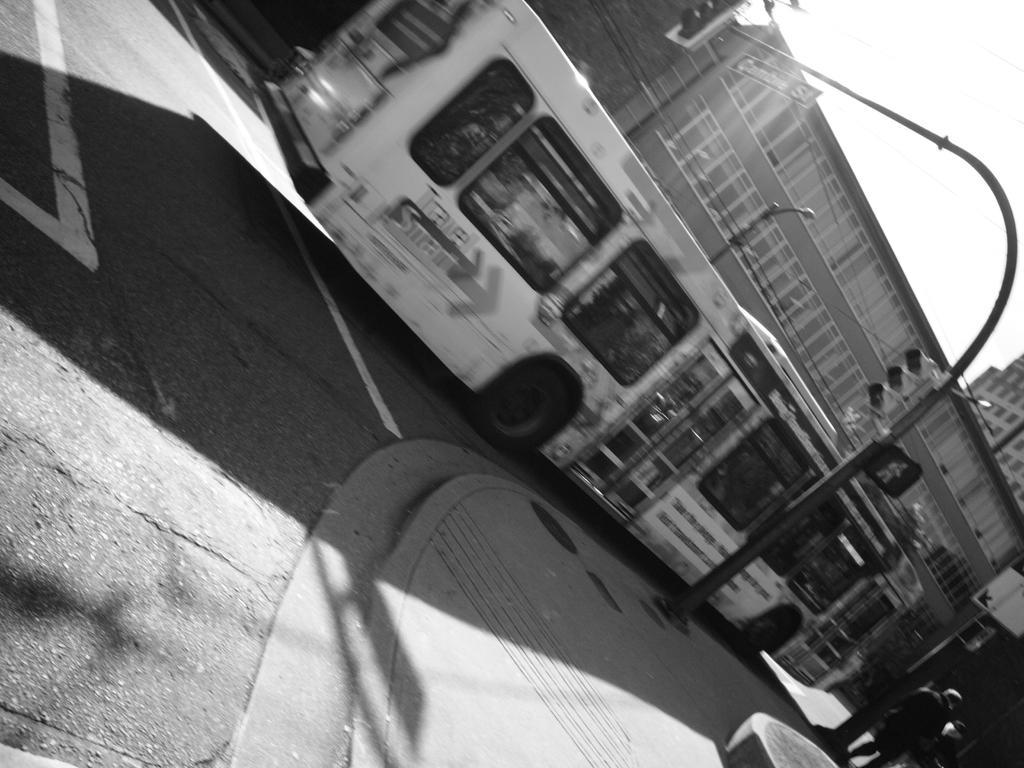Could you give a brief overview of what you see in this image? This is a black and white image. In this image, in the right corner, we can also see two people, pole and a land. In the right corner, we can also see a building. On the right side, we can see a traffic signal. In the middle of the image, we can see a bus moving on the road. In the background, we can see buildings, hoardings. At the top, we can see a sky, at the bottom, we can see a road and a footpath. 